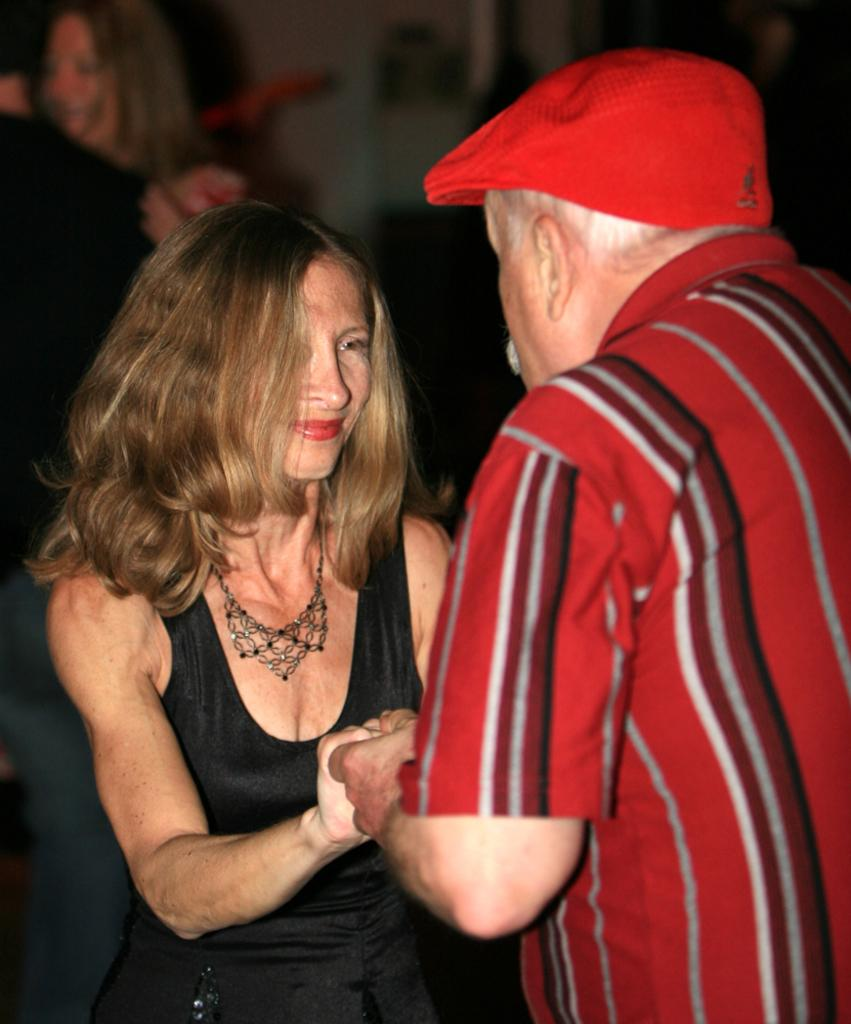Who are the people in the image? There is a man and a woman in the image. What are the man and woman doing in the image? The man and woman are holding hands and looking at each other. What type of food is the man eating in the image? There is no food present in the image; the man and woman are holding hands and looking at each other. Who is the actor playing the role of the man in the image? There is no actor or role-playing in the image; it is a candid photograph of a man and a woman. 